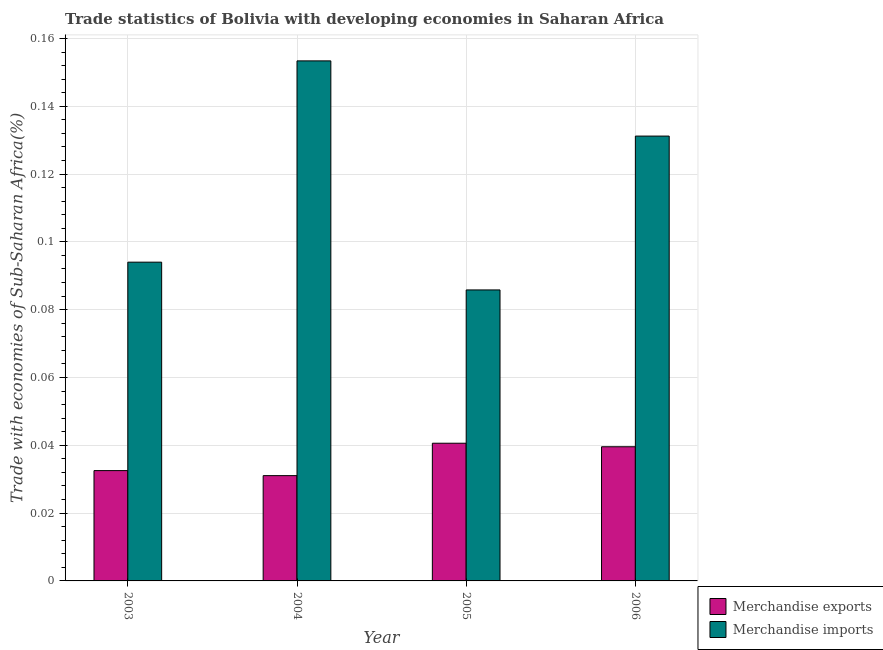How many different coloured bars are there?
Offer a very short reply. 2. How many groups of bars are there?
Make the answer very short. 4. Are the number of bars on each tick of the X-axis equal?
Your response must be concise. Yes. How many bars are there on the 2nd tick from the left?
Offer a very short reply. 2. How many bars are there on the 4th tick from the right?
Ensure brevity in your answer.  2. What is the label of the 3rd group of bars from the left?
Ensure brevity in your answer.  2005. In how many cases, is the number of bars for a given year not equal to the number of legend labels?
Offer a terse response. 0. What is the merchandise imports in 2006?
Make the answer very short. 0.13. Across all years, what is the maximum merchandise exports?
Offer a terse response. 0.04. Across all years, what is the minimum merchandise imports?
Keep it short and to the point. 0.09. In which year was the merchandise exports maximum?
Offer a very short reply. 2005. What is the total merchandise exports in the graph?
Ensure brevity in your answer.  0.14. What is the difference between the merchandise exports in 2003 and that in 2005?
Offer a terse response. -0.01. What is the difference between the merchandise imports in 2003 and the merchandise exports in 2004?
Ensure brevity in your answer.  -0.06. What is the average merchandise exports per year?
Keep it short and to the point. 0.04. In how many years, is the merchandise exports greater than 0.136 %?
Give a very brief answer. 0. What is the ratio of the merchandise imports in 2003 to that in 2005?
Offer a very short reply. 1.1. Is the merchandise imports in 2003 less than that in 2004?
Give a very brief answer. Yes. Is the difference between the merchandise imports in 2003 and 2005 greater than the difference between the merchandise exports in 2003 and 2005?
Make the answer very short. No. What is the difference between the highest and the second highest merchandise imports?
Give a very brief answer. 0.02. What is the difference between the highest and the lowest merchandise exports?
Your answer should be very brief. 0.01. Is the sum of the merchandise exports in 2003 and 2005 greater than the maximum merchandise imports across all years?
Ensure brevity in your answer.  Yes. What does the 2nd bar from the left in 2005 represents?
Make the answer very short. Merchandise imports. Does the graph contain any zero values?
Provide a short and direct response. No. How are the legend labels stacked?
Offer a very short reply. Vertical. What is the title of the graph?
Make the answer very short. Trade statistics of Bolivia with developing economies in Saharan Africa. What is the label or title of the X-axis?
Keep it short and to the point. Year. What is the label or title of the Y-axis?
Your answer should be compact. Trade with economies of Sub-Saharan Africa(%). What is the Trade with economies of Sub-Saharan Africa(%) of Merchandise exports in 2003?
Your response must be concise. 0.03. What is the Trade with economies of Sub-Saharan Africa(%) of Merchandise imports in 2003?
Your answer should be very brief. 0.09. What is the Trade with economies of Sub-Saharan Africa(%) of Merchandise exports in 2004?
Your response must be concise. 0.03. What is the Trade with economies of Sub-Saharan Africa(%) of Merchandise imports in 2004?
Provide a short and direct response. 0.15. What is the Trade with economies of Sub-Saharan Africa(%) in Merchandise exports in 2005?
Your response must be concise. 0.04. What is the Trade with economies of Sub-Saharan Africa(%) of Merchandise imports in 2005?
Give a very brief answer. 0.09. What is the Trade with economies of Sub-Saharan Africa(%) in Merchandise exports in 2006?
Offer a terse response. 0.04. What is the Trade with economies of Sub-Saharan Africa(%) in Merchandise imports in 2006?
Offer a very short reply. 0.13. Across all years, what is the maximum Trade with economies of Sub-Saharan Africa(%) of Merchandise exports?
Offer a terse response. 0.04. Across all years, what is the maximum Trade with economies of Sub-Saharan Africa(%) in Merchandise imports?
Give a very brief answer. 0.15. Across all years, what is the minimum Trade with economies of Sub-Saharan Africa(%) of Merchandise exports?
Offer a terse response. 0.03. Across all years, what is the minimum Trade with economies of Sub-Saharan Africa(%) in Merchandise imports?
Offer a very short reply. 0.09. What is the total Trade with economies of Sub-Saharan Africa(%) in Merchandise exports in the graph?
Provide a short and direct response. 0.14. What is the total Trade with economies of Sub-Saharan Africa(%) in Merchandise imports in the graph?
Provide a succinct answer. 0.46. What is the difference between the Trade with economies of Sub-Saharan Africa(%) in Merchandise exports in 2003 and that in 2004?
Your answer should be compact. 0. What is the difference between the Trade with economies of Sub-Saharan Africa(%) in Merchandise imports in 2003 and that in 2004?
Give a very brief answer. -0.06. What is the difference between the Trade with economies of Sub-Saharan Africa(%) of Merchandise exports in 2003 and that in 2005?
Provide a short and direct response. -0.01. What is the difference between the Trade with economies of Sub-Saharan Africa(%) of Merchandise imports in 2003 and that in 2005?
Your answer should be compact. 0.01. What is the difference between the Trade with economies of Sub-Saharan Africa(%) in Merchandise exports in 2003 and that in 2006?
Keep it short and to the point. -0.01. What is the difference between the Trade with economies of Sub-Saharan Africa(%) in Merchandise imports in 2003 and that in 2006?
Offer a very short reply. -0.04. What is the difference between the Trade with economies of Sub-Saharan Africa(%) in Merchandise exports in 2004 and that in 2005?
Your answer should be very brief. -0.01. What is the difference between the Trade with economies of Sub-Saharan Africa(%) of Merchandise imports in 2004 and that in 2005?
Your response must be concise. 0.07. What is the difference between the Trade with economies of Sub-Saharan Africa(%) in Merchandise exports in 2004 and that in 2006?
Keep it short and to the point. -0.01. What is the difference between the Trade with economies of Sub-Saharan Africa(%) in Merchandise imports in 2004 and that in 2006?
Ensure brevity in your answer.  0.02. What is the difference between the Trade with economies of Sub-Saharan Africa(%) in Merchandise exports in 2005 and that in 2006?
Make the answer very short. 0. What is the difference between the Trade with economies of Sub-Saharan Africa(%) of Merchandise imports in 2005 and that in 2006?
Offer a terse response. -0.05. What is the difference between the Trade with economies of Sub-Saharan Africa(%) in Merchandise exports in 2003 and the Trade with economies of Sub-Saharan Africa(%) in Merchandise imports in 2004?
Keep it short and to the point. -0.12. What is the difference between the Trade with economies of Sub-Saharan Africa(%) in Merchandise exports in 2003 and the Trade with economies of Sub-Saharan Africa(%) in Merchandise imports in 2005?
Ensure brevity in your answer.  -0.05. What is the difference between the Trade with economies of Sub-Saharan Africa(%) of Merchandise exports in 2003 and the Trade with economies of Sub-Saharan Africa(%) of Merchandise imports in 2006?
Provide a succinct answer. -0.1. What is the difference between the Trade with economies of Sub-Saharan Africa(%) in Merchandise exports in 2004 and the Trade with economies of Sub-Saharan Africa(%) in Merchandise imports in 2005?
Keep it short and to the point. -0.05. What is the difference between the Trade with economies of Sub-Saharan Africa(%) of Merchandise exports in 2004 and the Trade with economies of Sub-Saharan Africa(%) of Merchandise imports in 2006?
Make the answer very short. -0.1. What is the difference between the Trade with economies of Sub-Saharan Africa(%) of Merchandise exports in 2005 and the Trade with economies of Sub-Saharan Africa(%) of Merchandise imports in 2006?
Offer a terse response. -0.09. What is the average Trade with economies of Sub-Saharan Africa(%) in Merchandise exports per year?
Make the answer very short. 0.04. What is the average Trade with economies of Sub-Saharan Africa(%) in Merchandise imports per year?
Give a very brief answer. 0.12. In the year 2003, what is the difference between the Trade with economies of Sub-Saharan Africa(%) of Merchandise exports and Trade with economies of Sub-Saharan Africa(%) of Merchandise imports?
Provide a succinct answer. -0.06. In the year 2004, what is the difference between the Trade with economies of Sub-Saharan Africa(%) of Merchandise exports and Trade with economies of Sub-Saharan Africa(%) of Merchandise imports?
Provide a short and direct response. -0.12. In the year 2005, what is the difference between the Trade with economies of Sub-Saharan Africa(%) of Merchandise exports and Trade with economies of Sub-Saharan Africa(%) of Merchandise imports?
Ensure brevity in your answer.  -0.05. In the year 2006, what is the difference between the Trade with economies of Sub-Saharan Africa(%) of Merchandise exports and Trade with economies of Sub-Saharan Africa(%) of Merchandise imports?
Your response must be concise. -0.09. What is the ratio of the Trade with economies of Sub-Saharan Africa(%) in Merchandise exports in 2003 to that in 2004?
Offer a terse response. 1.05. What is the ratio of the Trade with economies of Sub-Saharan Africa(%) of Merchandise imports in 2003 to that in 2004?
Provide a succinct answer. 0.61. What is the ratio of the Trade with economies of Sub-Saharan Africa(%) of Merchandise exports in 2003 to that in 2005?
Ensure brevity in your answer.  0.8. What is the ratio of the Trade with economies of Sub-Saharan Africa(%) in Merchandise imports in 2003 to that in 2005?
Ensure brevity in your answer.  1.1. What is the ratio of the Trade with economies of Sub-Saharan Africa(%) in Merchandise exports in 2003 to that in 2006?
Give a very brief answer. 0.82. What is the ratio of the Trade with economies of Sub-Saharan Africa(%) of Merchandise imports in 2003 to that in 2006?
Your response must be concise. 0.72. What is the ratio of the Trade with economies of Sub-Saharan Africa(%) in Merchandise exports in 2004 to that in 2005?
Keep it short and to the point. 0.76. What is the ratio of the Trade with economies of Sub-Saharan Africa(%) in Merchandise imports in 2004 to that in 2005?
Provide a succinct answer. 1.79. What is the ratio of the Trade with economies of Sub-Saharan Africa(%) of Merchandise exports in 2004 to that in 2006?
Offer a very short reply. 0.78. What is the ratio of the Trade with economies of Sub-Saharan Africa(%) in Merchandise imports in 2004 to that in 2006?
Provide a succinct answer. 1.17. What is the ratio of the Trade with economies of Sub-Saharan Africa(%) of Merchandise exports in 2005 to that in 2006?
Make the answer very short. 1.03. What is the ratio of the Trade with economies of Sub-Saharan Africa(%) of Merchandise imports in 2005 to that in 2006?
Ensure brevity in your answer.  0.65. What is the difference between the highest and the second highest Trade with economies of Sub-Saharan Africa(%) in Merchandise imports?
Your answer should be very brief. 0.02. What is the difference between the highest and the lowest Trade with economies of Sub-Saharan Africa(%) in Merchandise exports?
Your answer should be very brief. 0.01. What is the difference between the highest and the lowest Trade with economies of Sub-Saharan Africa(%) in Merchandise imports?
Provide a succinct answer. 0.07. 